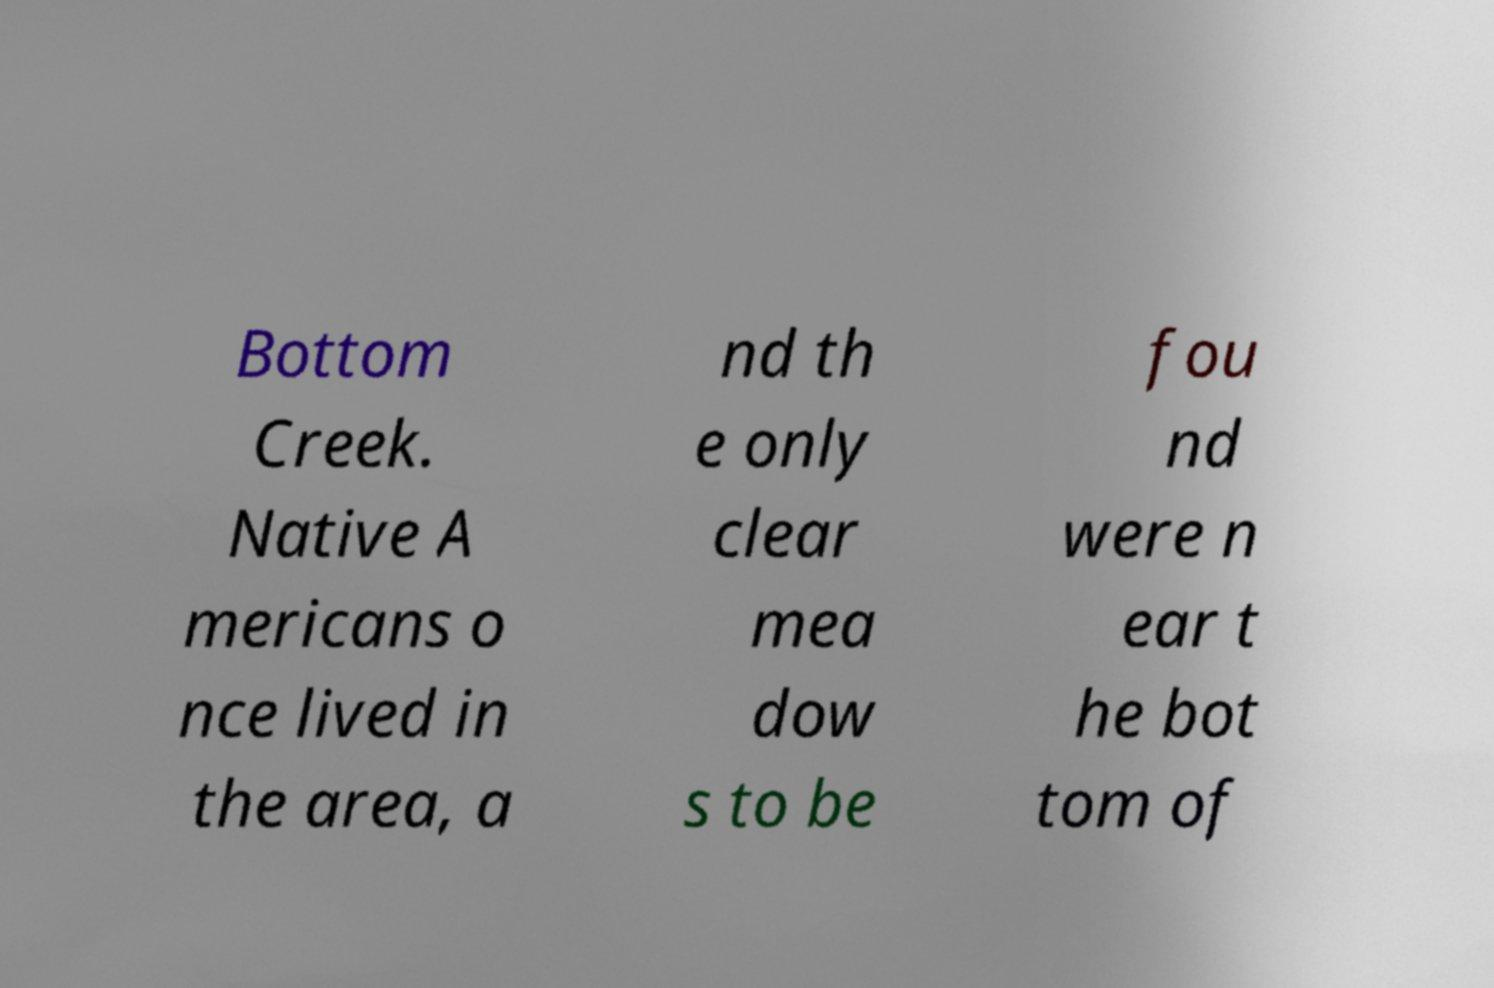For documentation purposes, I need the text within this image transcribed. Could you provide that? Bottom Creek. Native A mericans o nce lived in the area, a nd th e only clear mea dow s to be fou nd were n ear t he bot tom of 